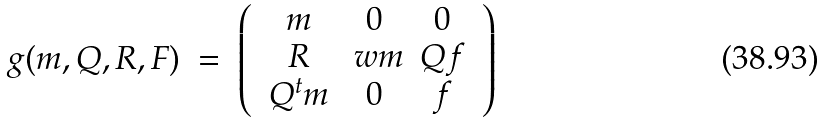<formula> <loc_0><loc_0><loc_500><loc_500>g ( m , Q , R , F ) \ = \ \left ( \ \begin{array} { c c c } m & 0 & 0 \\ R & \ w { m } & Q f \\ Q ^ { t } m & 0 & f \\ \end{array} \ \right )</formula> 